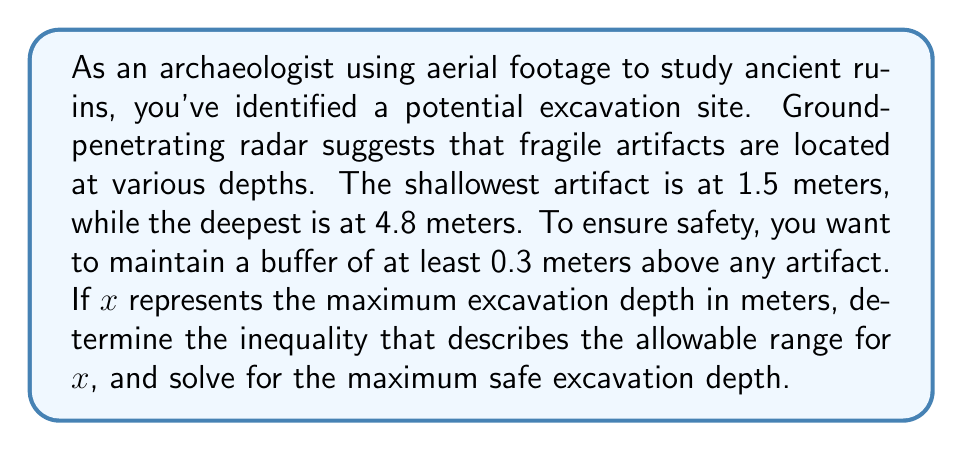Can you solve this math problem? Let's approach this step-by-step:

1) We need to ensure that our excavation depth ($x$) is:
   a) Deep enough to be worthwhile (greater than 0)
   b) Shallower than the shallowest artifact minus the safety buffer

2) The shallowest artifact is at 1.5 meters. We need to maintain a 0.3-meter buffer above this.

3) Therefore, our maximum depth should be:
   $1.5 - 0.3 = 1.2$ meters

4) We can express this as an inequality:
   $0 < x \leq 1.2$

5) To solve for the maximum safe excavation depth, we simply need to find the upper bound of this inequality, which is 1.2 meters.

This approach ensures that we can excavate as deep as possible while maintaining the safety buffer above the shallowest artifact. The deeper artifacts (up to 4.8 meters) are automatically protected by this conservative approach.
Answer: The inequality describing the allowable range for excavation depth is:
$0 < x \leq 1.2$

The maximum safe excavation depth is 1.2 meters. 